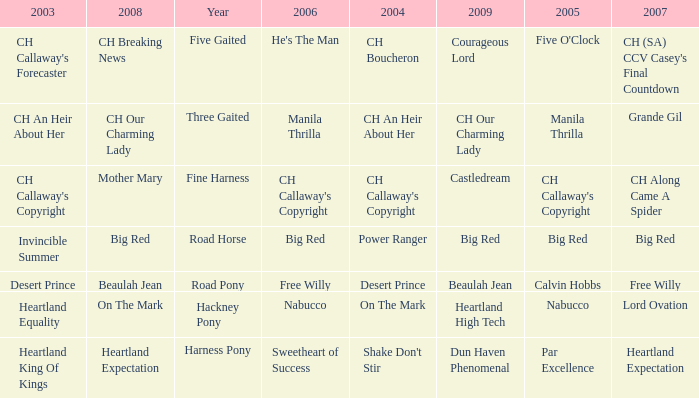What year is the 2007 big red? Road Horse. 